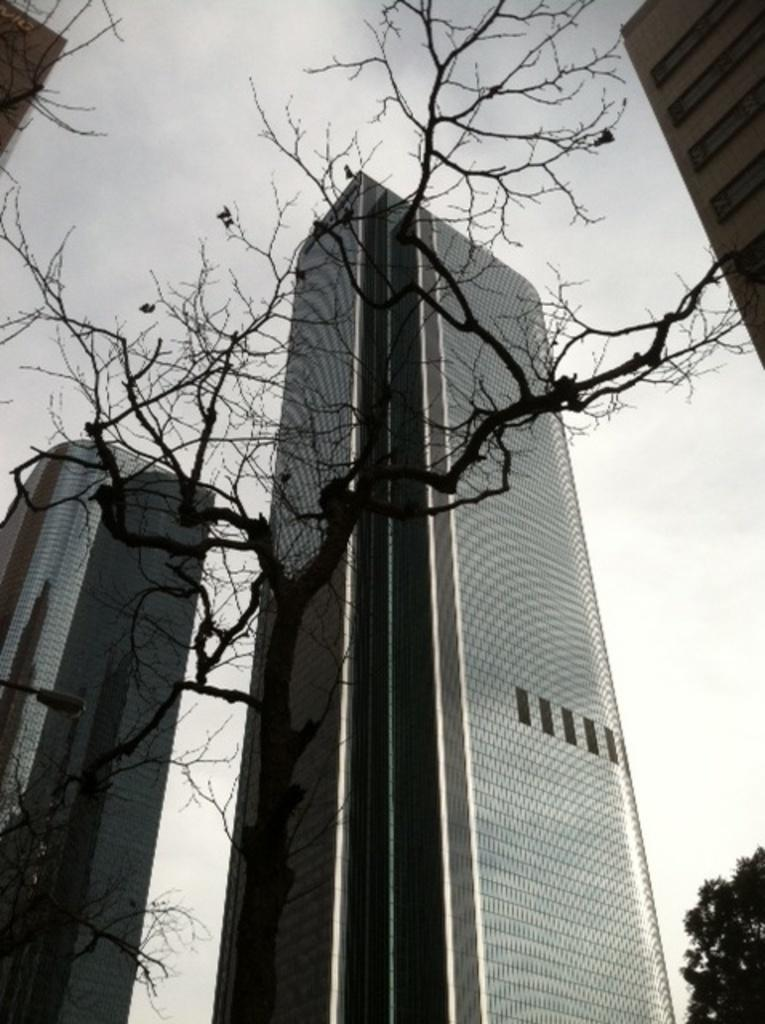What type of vegetation can be seen in the image? There are trees in the image. What type of structures are visible in the image? There are huge buildings in the image. What is the condition of the sky in the image? The sky is cloudy in the image. Can you tell me how many maids are present in the image? There is no mention of a maid in the image; it features trees, huge buildings, and a cloudy sky. What type of pin can be seen holding the buildings together in the image? There is no pin present in the image; the buildings are not held together by any visible pins. 